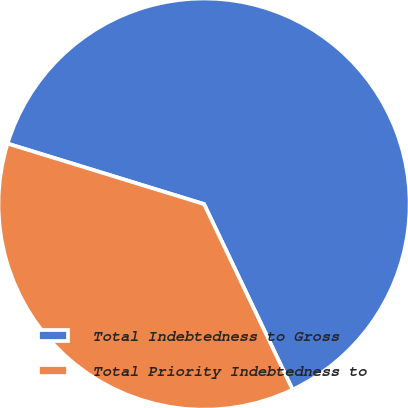Convert chart. <chart><loc_0><loc_0><loc_500><loc_500><pie_chart><fcel>Total Indebtedness to Gross<fcel>Total Priority Indebtedness to<nl><fcel>63.16%<fcel>36.84%<nl></chart> 